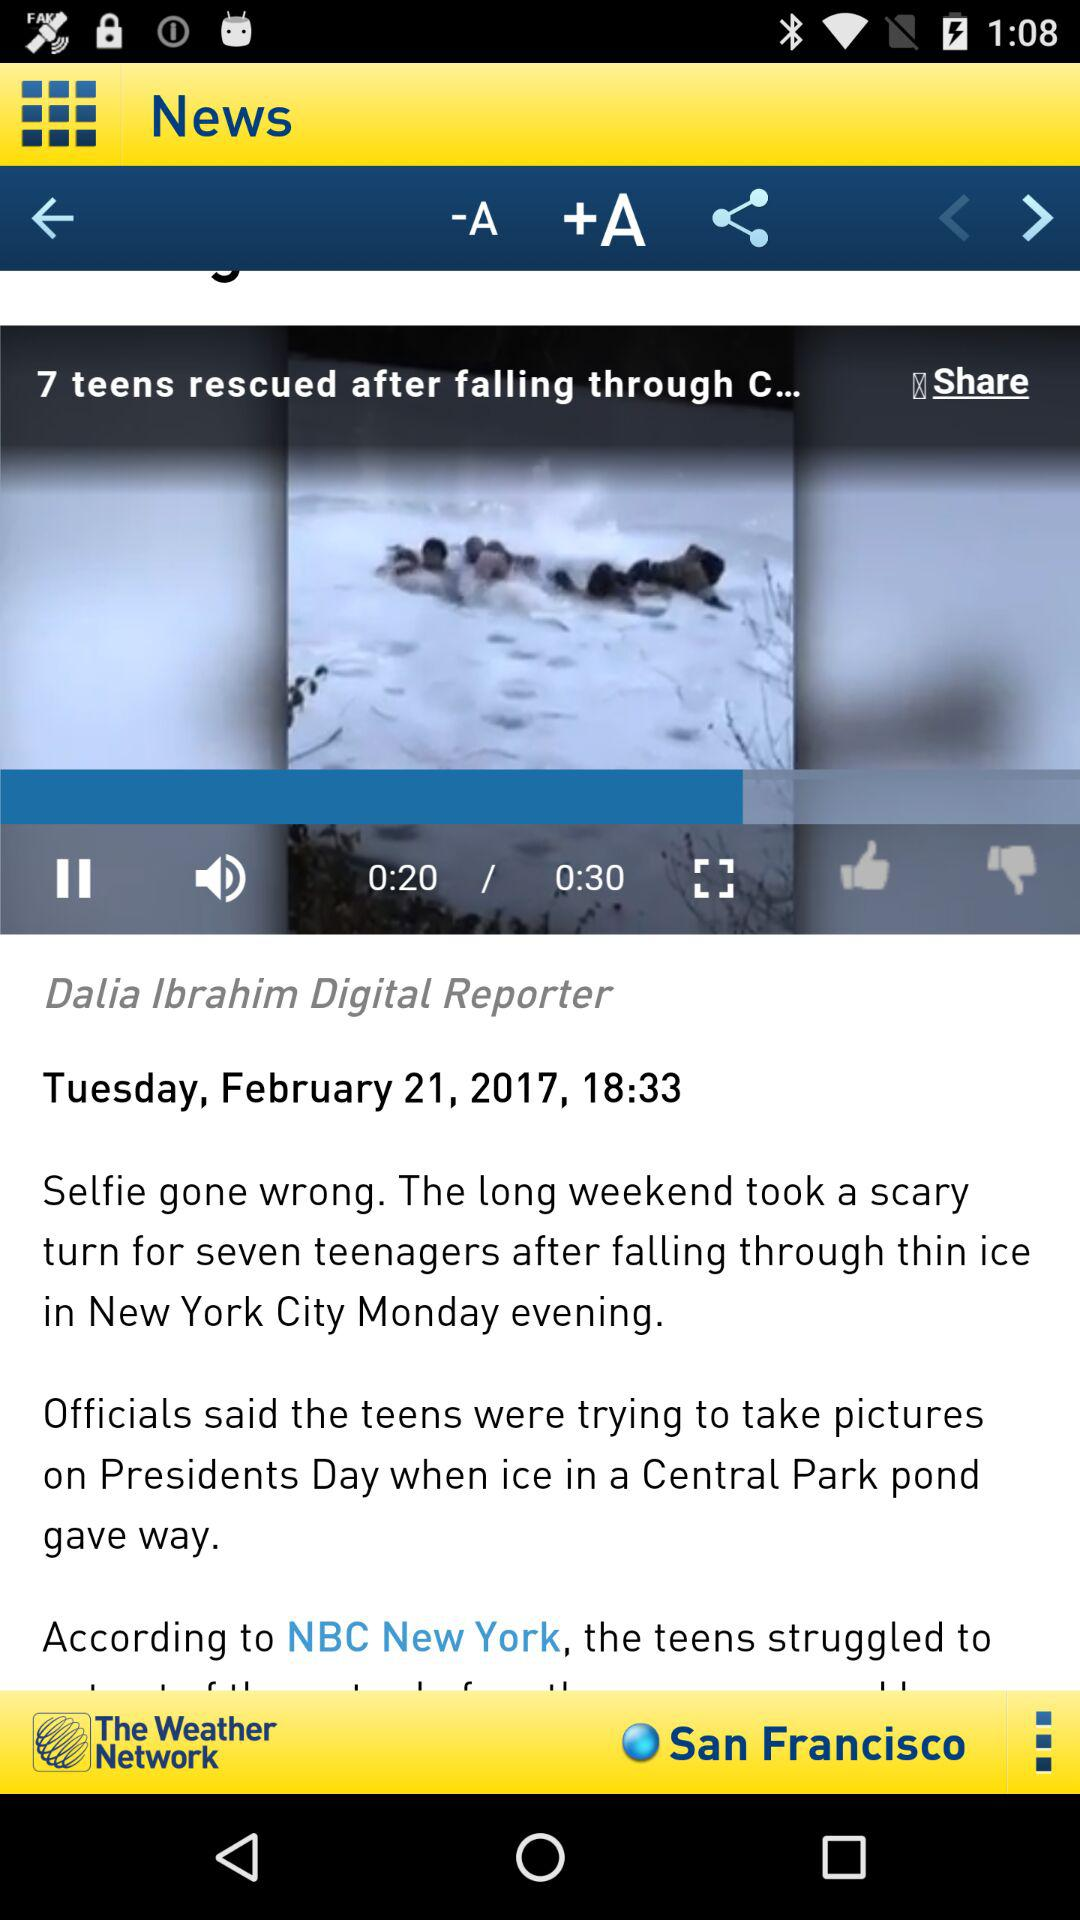How long is the video? The video is 30 seconds long. 